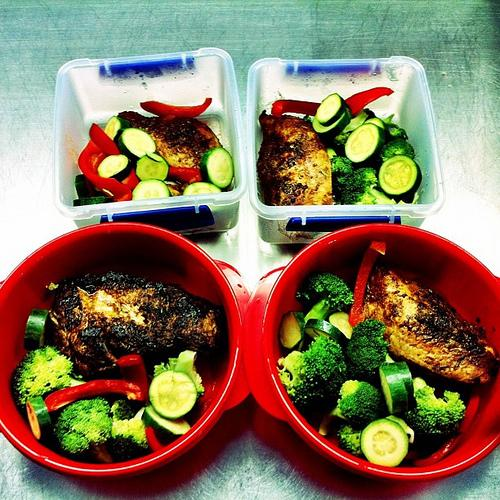What do you think is the sentiment evoked by this image? The image evokes a sense of a healthy, delicious, and convenient meal, perfect for a lunch on the go. In a brief sentence, describe what the main components of this image are. This image contains two red bowls and two white containers with blue handles, holding grilled chicken, vegetables, and cucumbers. What are the shapes of the main dishware featured in the image? The red bowls are round, and the white containers are square. List the main food-related items found in the red bowls and their colors. Grilled chicken (brown), broccoli (green), red pepper (red), and cucumber slices (green). What could be the purpose of the containers in the image? The containers serve as portable storage for a portion of a meal or lunch on-the-go. Count the number of red peppers and broccoli as part of the dishes. There is one slice of red pepper and one broccoli floret as part of the dishes. Briefly describe the type of meat featured in the image. The meat is a barbecued, blackened chicken breast served with vegetables. Describe the condition of the vegetables in the red bowls. The vegetables in the red bowls are cooked and include broccoli, sliced red peppers, and cucumber. How many red bowls and white containers are in the image, and what is their unique characteristic? There are two red bowls and two white containers, with the containers having blue handles. Which vegetables are included in the vegetable medley in the red bowls? The vegetable medley contains cooked broccoli, red peppers, and zucchini. Observe the purple container of ketchup next to the white containers. There is no mention of a purple container of ketchup in the image information. The instruction is misleading because it introduces an object that is not present in the image. Look for a tall glass of orange juice sitting next to the red bowls. There is no mention of a tall glass of orange juice in the given image information. This instruction is misleading because it suggests the presence of an object that does not exist in the image. Can you find the yellow banana in the bowl with the chicken breast? There is no mention of a yellow banana in the given image information. The instruction is misleading because it introduces a non-existent object in the form of the yellow banana. Is there a blue napkin tucked under the table in the image? There is no mention of a blue napkin in the given image information. The instruction is misleading because it asks a question about an object that does not exist in the image. Identify the green spatula resting on the edge of the right container. The given image information does not mention a green spatula. The instruction is misleading because it directs the user to look for an object that is not present in the image. Notice the silver fork lying on top of the grilled chicken in the left bowl. There is no mention of a silver fork in the image information. The instruction is misleading because it describes a non-existent object as if it were present in the image. 